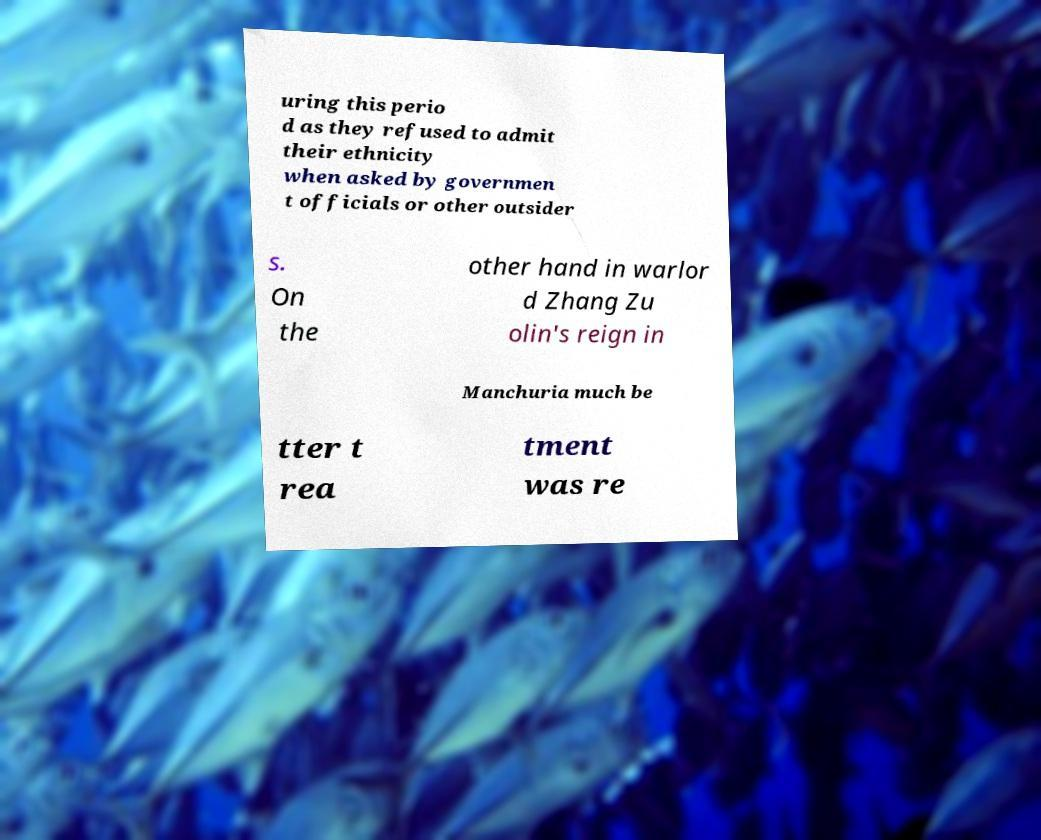I need the written content from this picture converted into text. Can you do that? uring this perio d as they refused to admit their ethnicity when asked by governmen t officials or other outsider s. On the other hand in warlor d Zhang Zu olin's reign in Manchuria much be tter t rea tment was re 